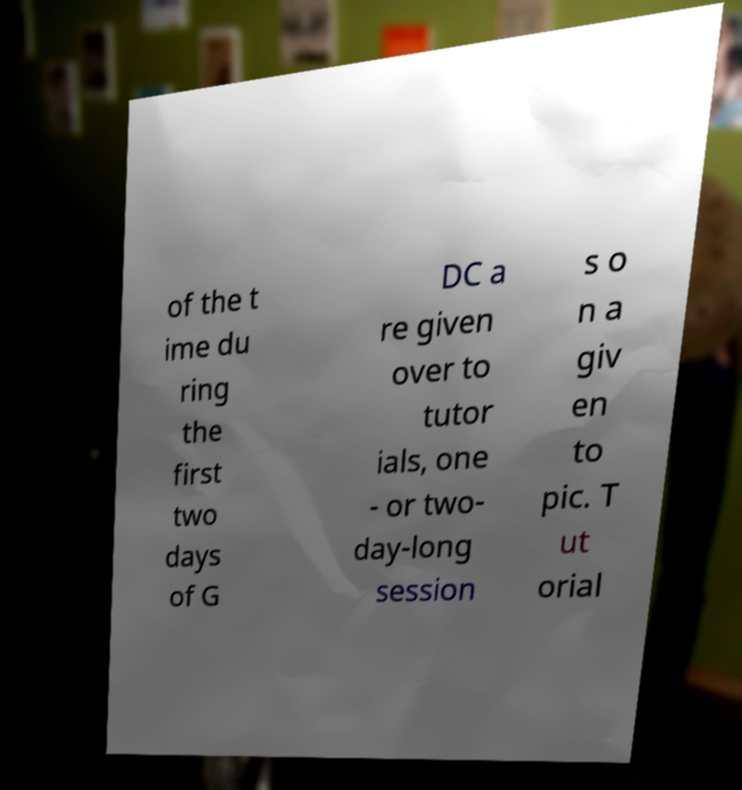Could you assist in decoding the text presented in this image and type it out clearly? of the t ime du ring the first two days of G DC a re given over to tutor ials, one - or two- day-long session s o n a giv en to pic. T ut orial 